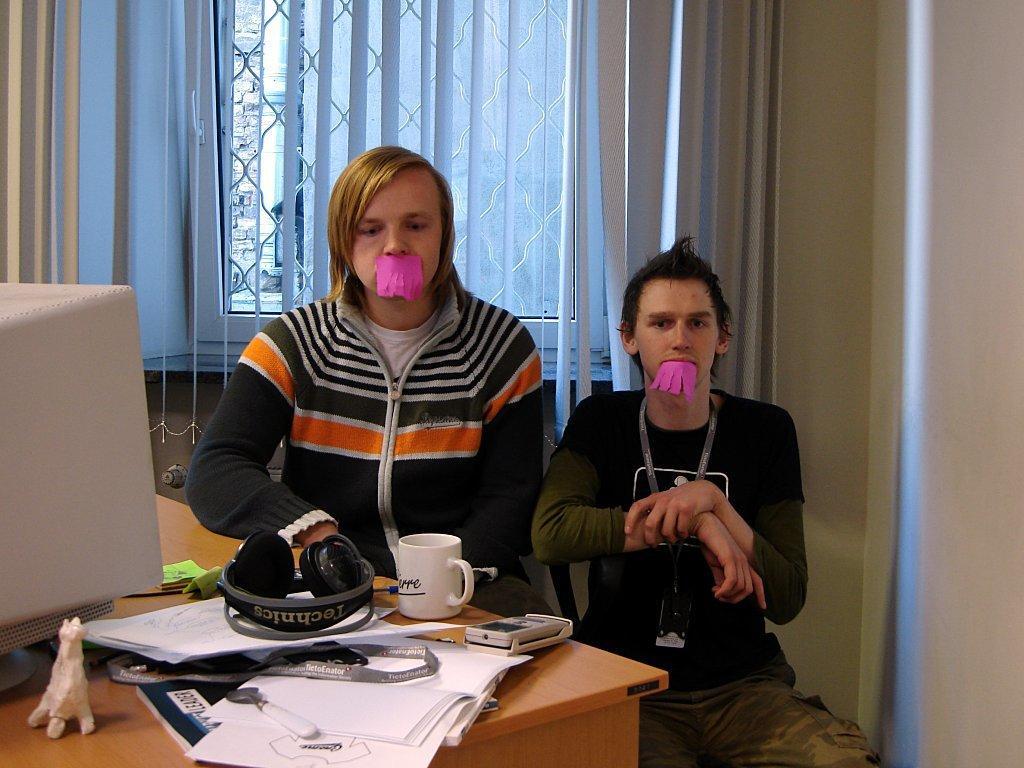Could you give a brief overview of what you see in this image? In the image two persons sitting on a chair. Bottom left side of the image there is a table on the table there are some papers and books and there is a headphones and cup. Behind them there is a window and curtain. 